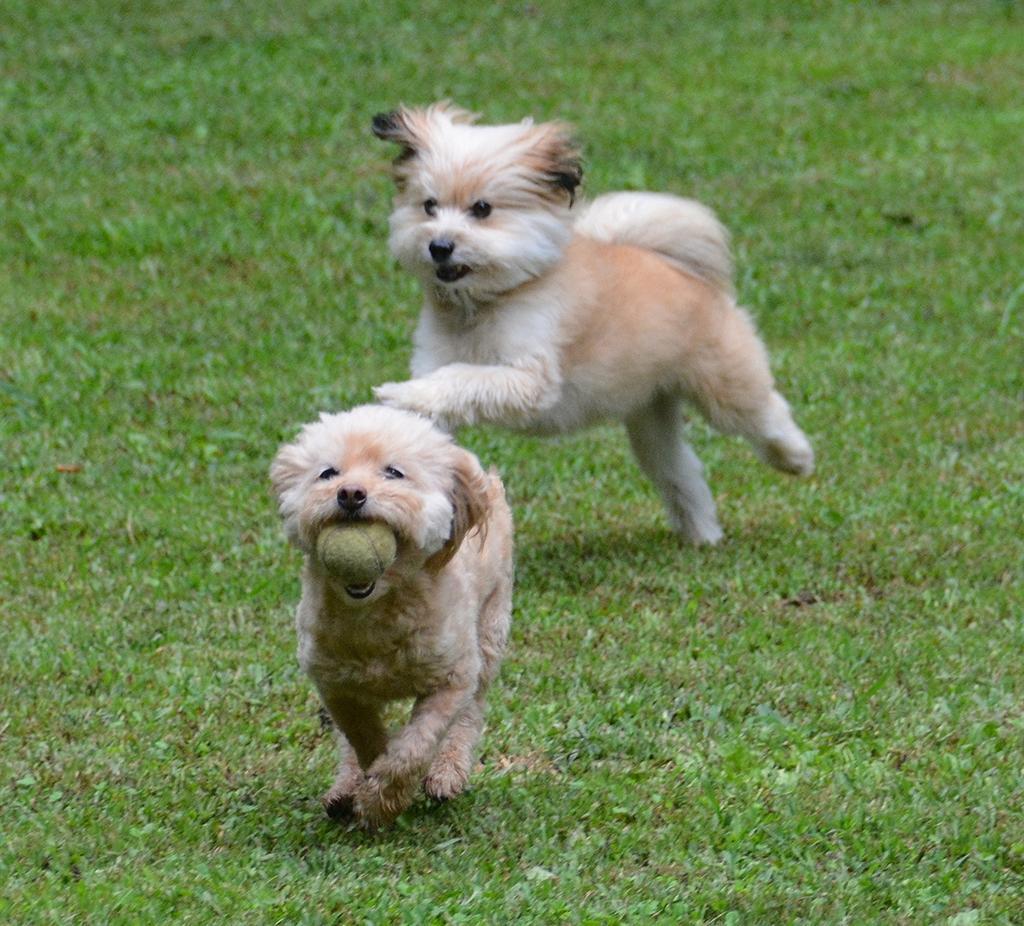Could you give a brief overview of what you see in this image? In this image we can see two puppies running at the foreground of the image there is puppy which has ball in her mouth and at the background of the image there is ground. 